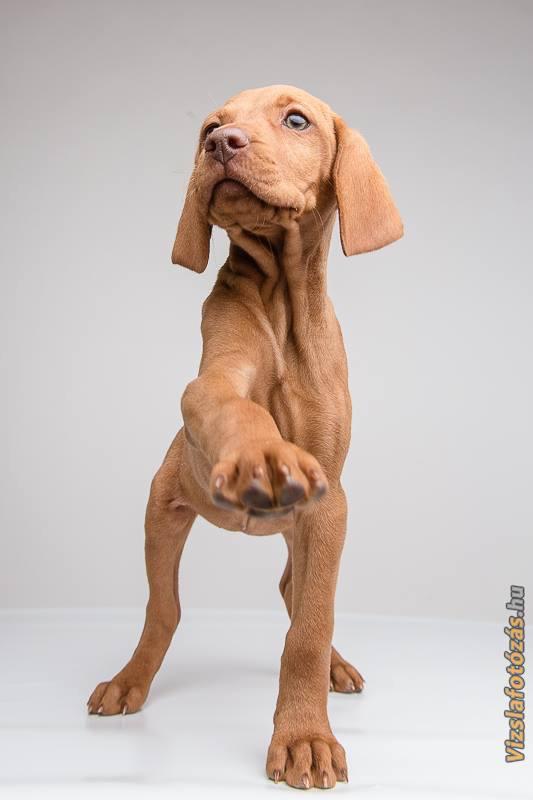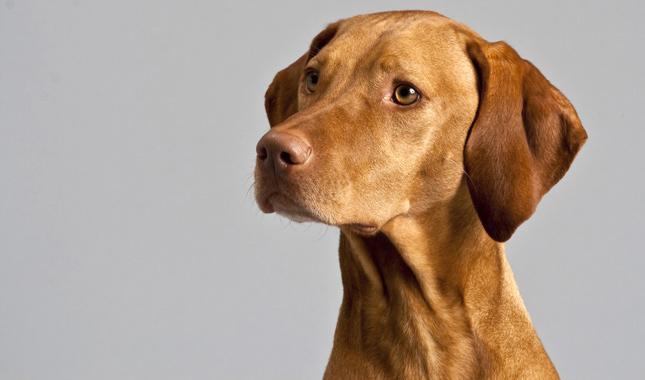The first image is the image on the left, the second image is the image on the right. Given the left and right images, does the statement "A dog is wearing a collar." hold true? Answer yes or no. No. The first image is the image on the left, the second image is the image on the right. For the images shown, is this caption "The left and right image contains the same number of dogs with one puppy and one adult." true? Answer yes or no. Yes. 